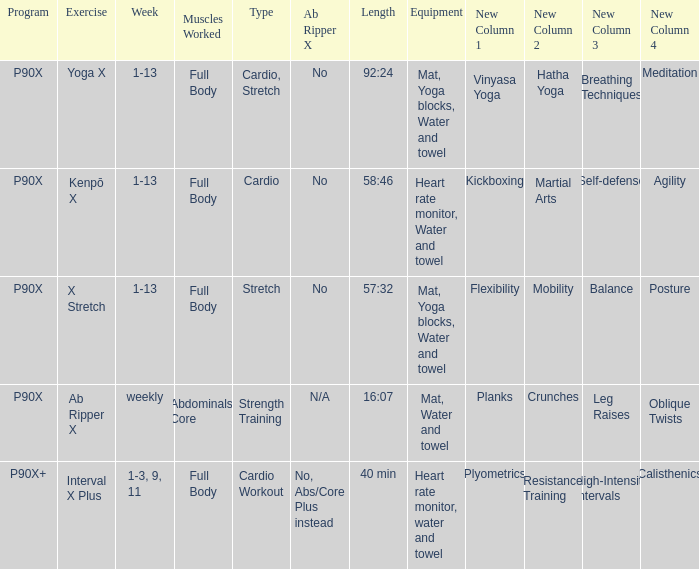What is the week when the kind is cardio exercise? 1-3, 9, 11. 